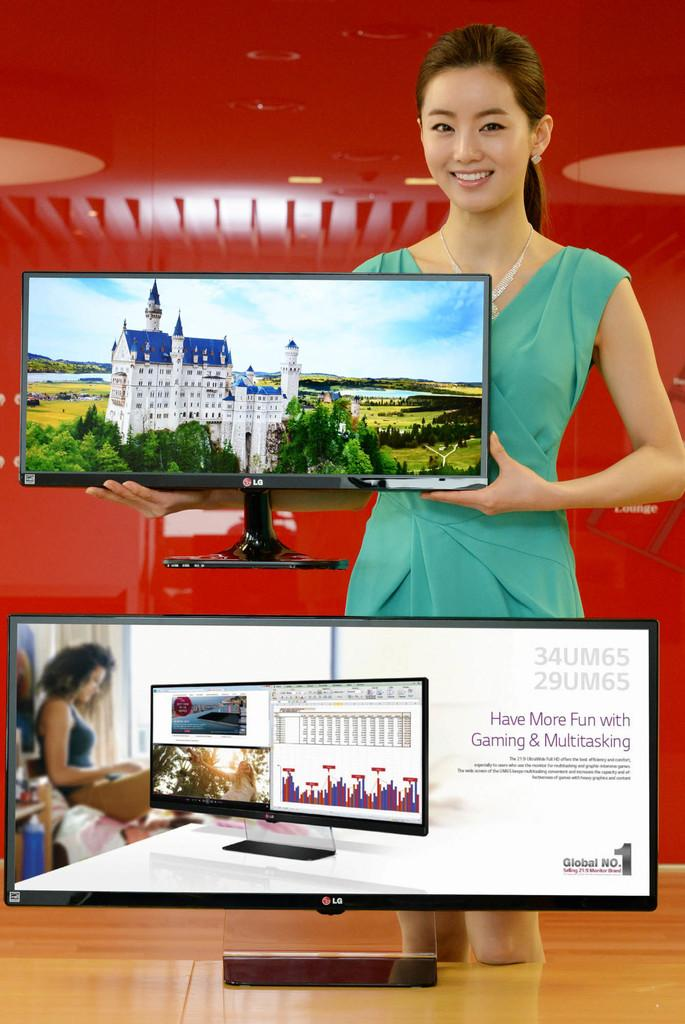Provide a one-sentence caption for the provided image. a woman displaying two LG monitors and red backdrop. 